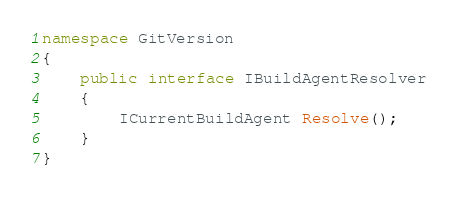<code> <loc_0><loc_0><loc_500><loc_500><_C#_>namespace GitVersion
{
    public interface IBuildAgentResolver
    {
        ICurrentBuildAgent Resolve();
    }
}
</code> 